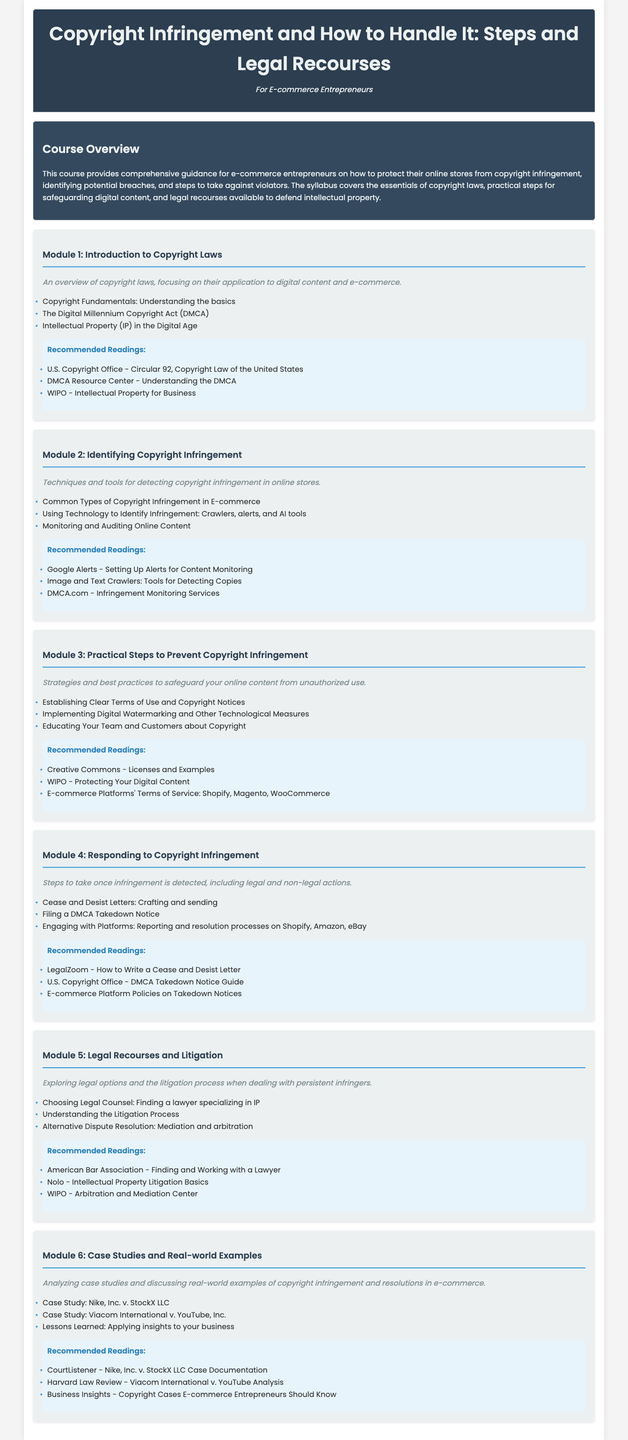What is the title of the course? The title of the course is found in the header section of the document.
Answer: Copyright Infringement and How to Handle It: Steps and Legal Recourses How many modules are in the syllabus? The total number of modules can be counted in the document.
Answer: Six Which module covers legal recourses? This information can be retrieved by looking for the module that specifically mentions legal actions.
Answer: Module 5: Legal Recourses and Litigation What is the focus of Module 2? The focus can be identified from the module description in the syllabus.
Answer: Identifying Copyright Infringement What type of letter is mentioned in Module 4? This question targets specific content related to actions taken against infringement.
Answer: Cease and Desist Letters Which guideline is recommended for filing a DMCA Takedown Notice? The reading recommendations provide specific resources related to filing actions.
Answer: U.S. Copyright Office - DMCA Takedown Notice Guide What does Module 6 analyze? The module description indicates the content of this module.
Answer: Case Studies and Real-world Examples Who is one of the recommended readings for understanding IP litigation? This can be found in the readings section of Module 5.
Answer: Nolo - Intellectual Property Litigation Basics What act is discussed in Module 1? The specific act is mentioned in the context of copyright laws.
Answer: The Digital Millennium Copyright Act (DMCA) 